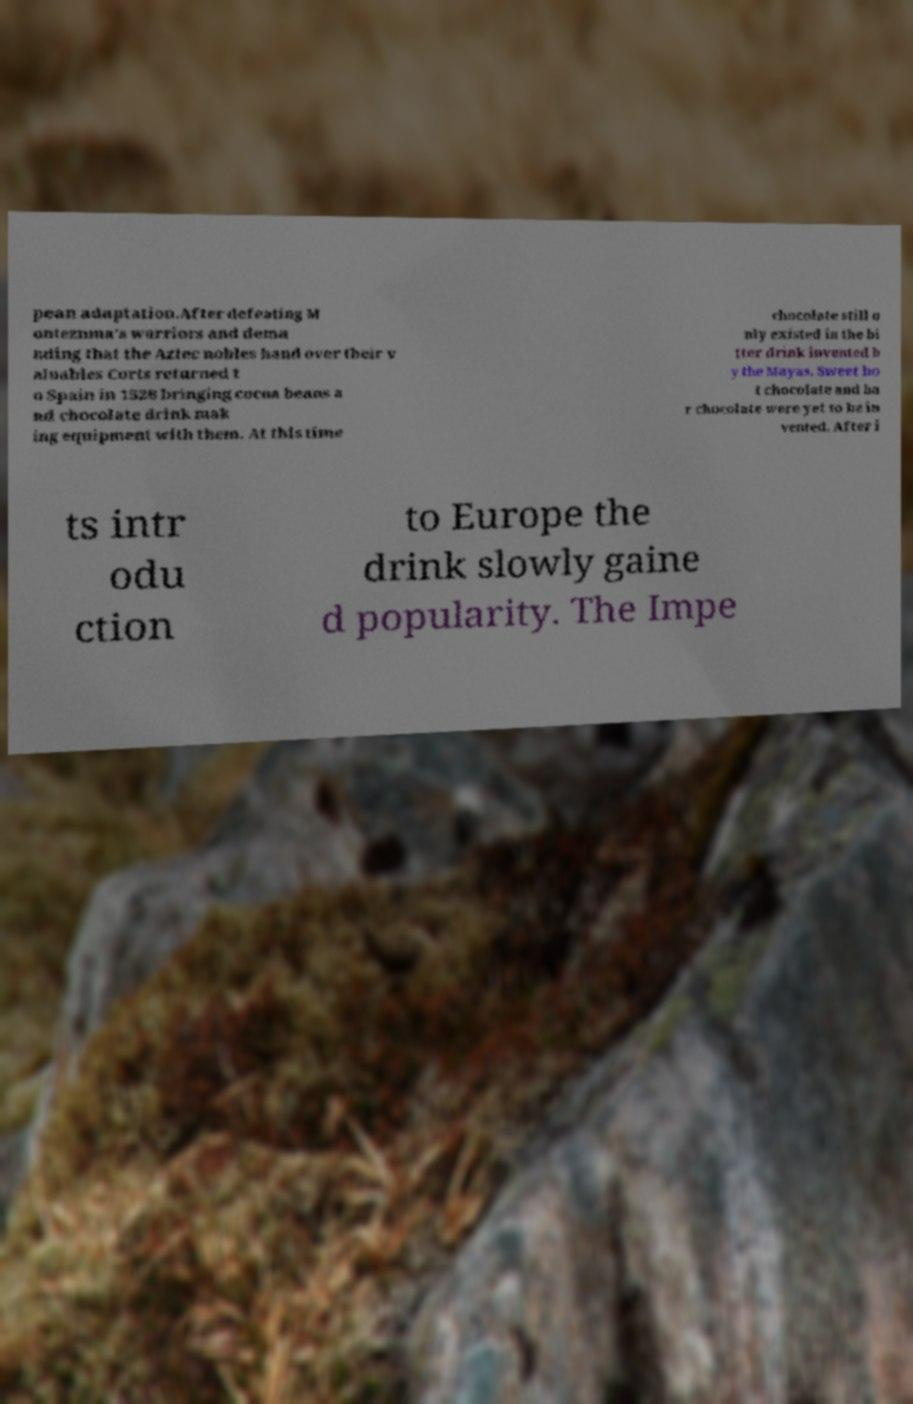Can you read and provide the text displayed in the image?This photo seems to have some interesting text. Can you extract and type it out for me? pean adaptation.After defeating M ontezuma's warriors and dema nding that the Aztec nobles hand over their v aluables Corts returned t o Spain in 1528 bringing cocoa beans a nd chocolate drink mak ing equipment with them. At this time chocolate still o nly existed in the bi tter drink invented b y the Mayas. Sweet ho t chocolate and ba r chocolate were yet to be in vented. After i ts intr odu ction to Europe the drink slowly gaine d popularity. The Impe 